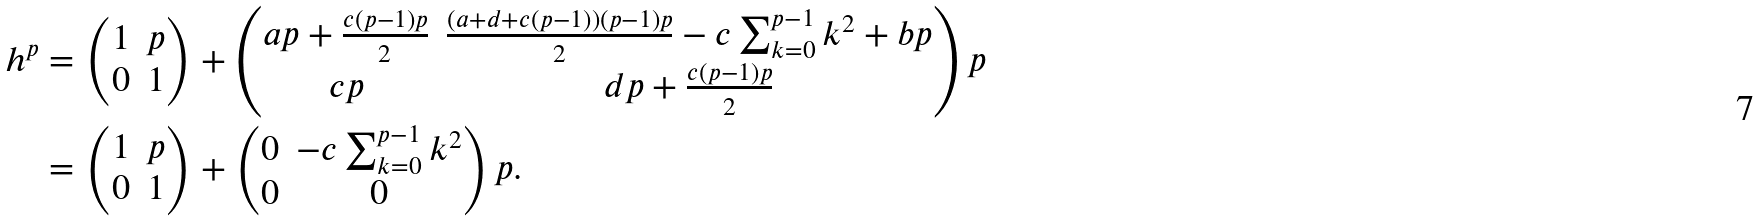Convert formula to latex. <formula><loc_0><loc_0><loc_500><loc_500>h ^ { p } & = \begin{pmatrix} 1 & p \\ 0 & 1 \end{pmatrix} + \begin{pmatrix} a p + \frac { c ( p - 1 ) p } { 2 } & \frac { ( a + d + c ( p - 1 ) ) ( p - 1 ) p } { 2 } - c \sum _ { k = 0 } ^ { p - 1 } k ^ { 2 } + b p \\ c p & d p + \frac { c ( p - 1 ) p } { 2 } \end{pmatrix} p \\ & = \begin{pmatrix} 1 & p \\ 0 & 1 \end{pmatrix} + \begin{pmatrix} 0 & - c \sum _ { k = 0 } ^ { p - 1 } k ^ { 2 } \\ 0 & 0 \end{pmatrix} p .</formula> 